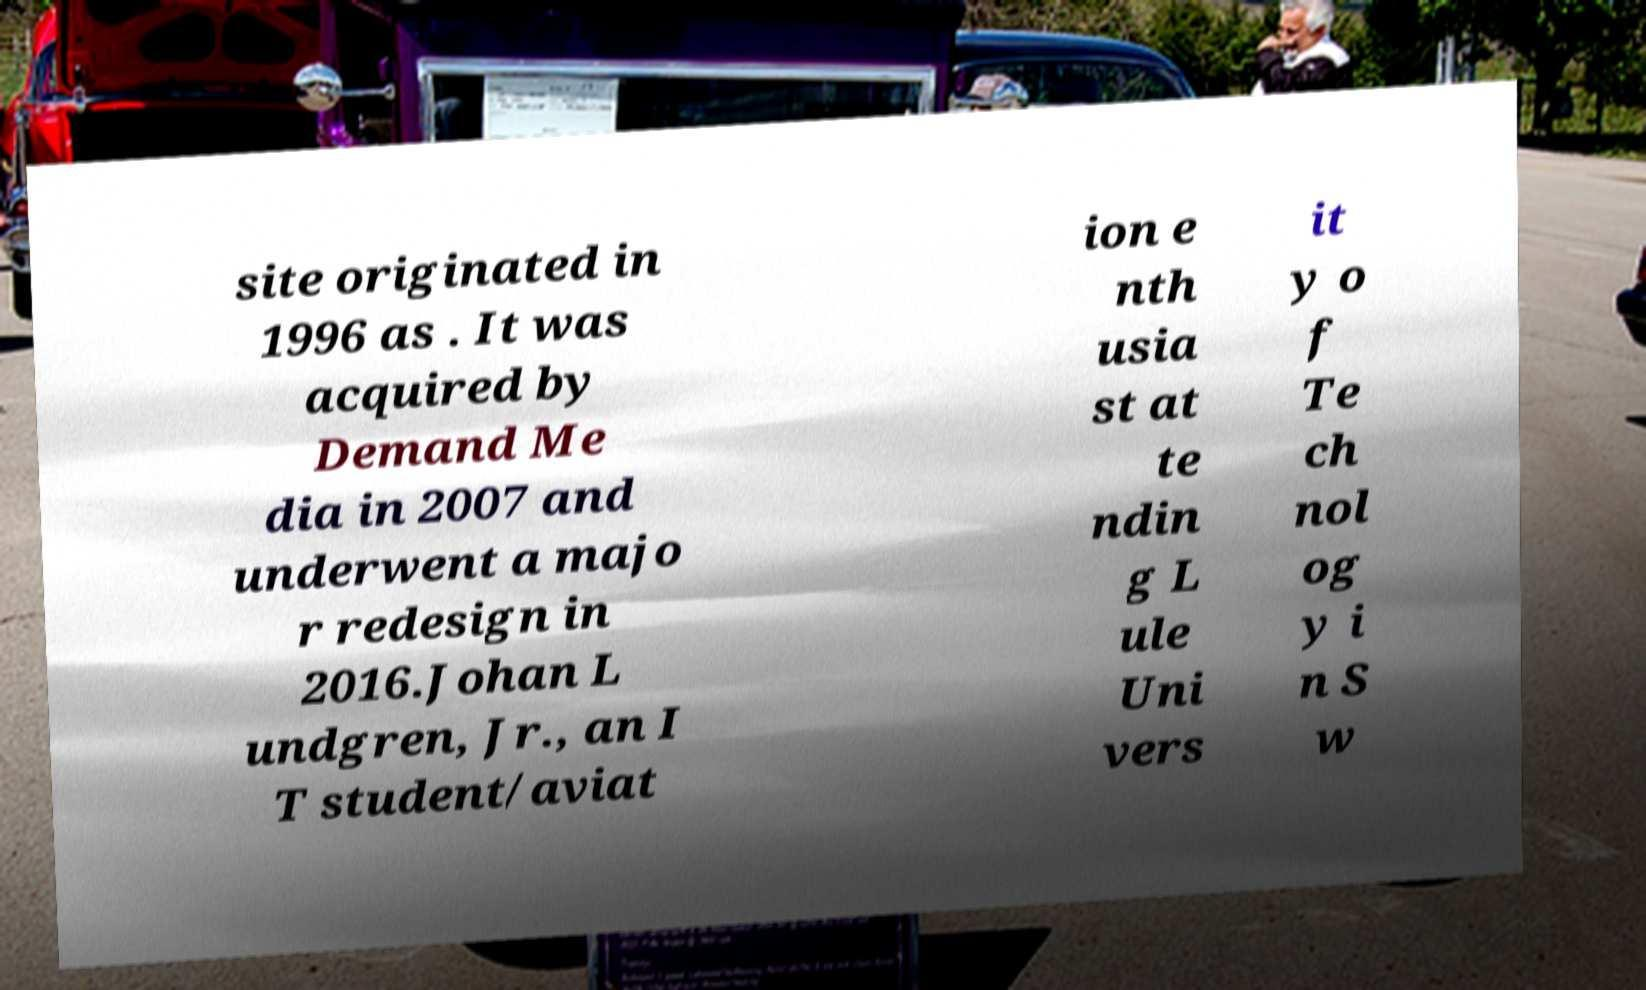What messages or text are displayed in this image? I need them in a readable, typed format. site originated in 1996 as . It was acquired by Demand Me dia in 2007 and underwent a majo r redesign in 2016.Johan L undgren, Jr., an I T student/aviat ion e nth usia st at te ndin g L ule Uni vers it y o f Te ch nol og y i n S w 